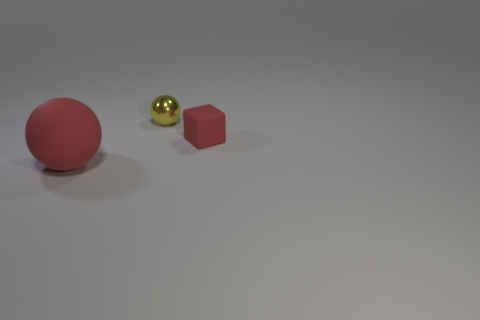What textures are present among the objects in this image? The red ball has a matte-like texture, while the small yellow ball seems to have a glossy or shiny surface. The cube appears to have a flat or possibly slightly rough texture. 